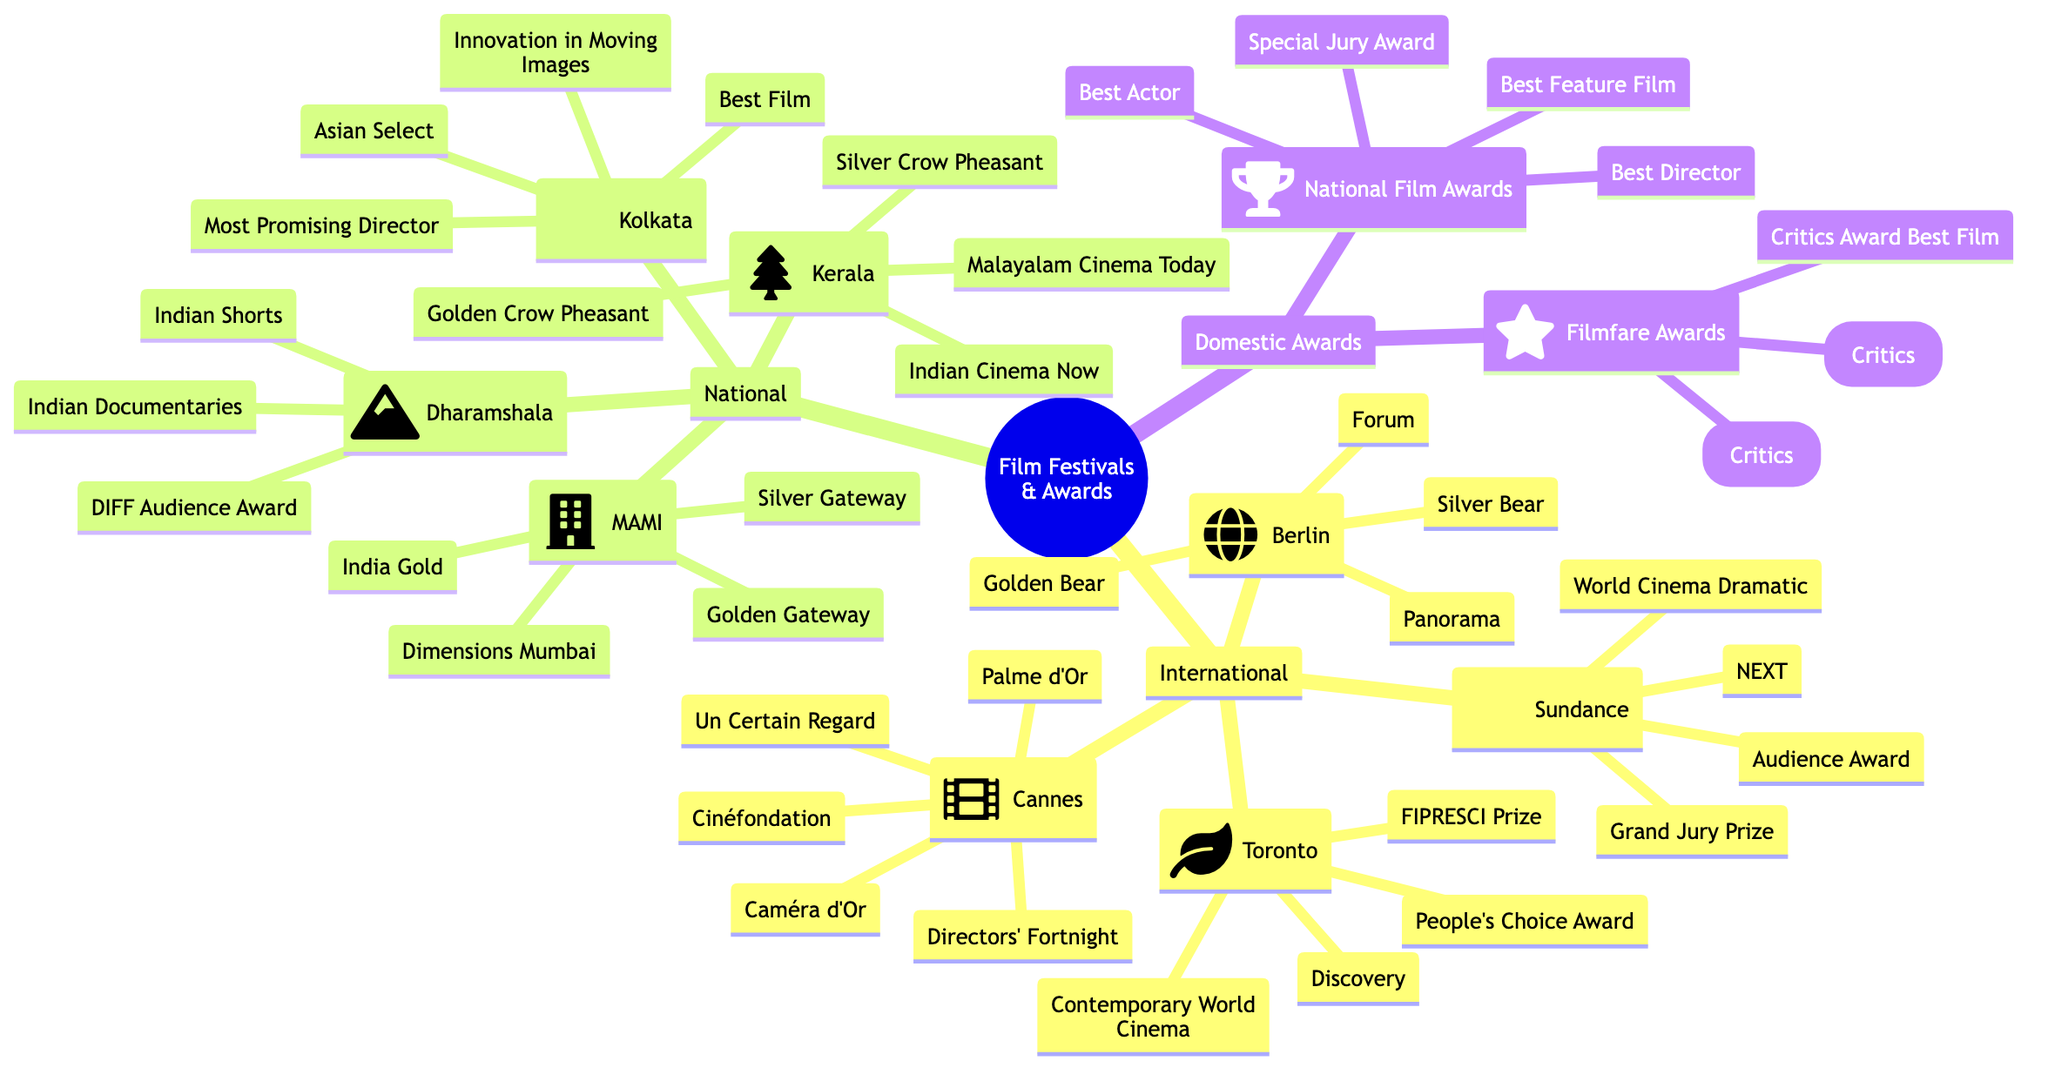What are the two notable awards given at the Cannes Film Festival? The diagram specifies that the notable awards for Cannes are the Palme d'Or and Caméra d'Or.
Answer: Palme d'Or, Caméra d'Or How many key sections are there in the Sundance Film Festival? According to the diagram, the Sundance Film Festival has two key sections: World Cinema Dramatic Competition and NEXT.
Answer: 2 What is one of the notable awards for the Toronto International Film Festival? The diagram lists the People's Choice Award and FIPRESCI Prize as notable awards for the Toronto International Film Festival.
Answer: People's Choice Award Which film festival features a section called "Indian Shorts"? The Dharamshala International Film Festival has a key section called Indian Shorts, as mentioned in the diagram.
Answer: Dharamshala International Film Festival How many national film festivals are represented in the diagram? The diagram shows four national film festivals: Mumbai Film Festival (MAMI), Kolkata International Film Festival, Kerala International Film Festival, and Dharamshala International Film Festival.
Answer: 4 What categories are included in the National Film Awards? The diagram indicates that the National Film Awards include Best Feature Film, Best Director, Best Actor, and Special Jury Award as categories.
Answer: Best Feature Film, Best Director, Best Actor, Special Jury Award Which festival awards the Golden Gateway and Silver Gateway? The Mumbai Film Festival (MAMI) awards the Golden Gateway and Silver Gateway, as stated in the diagram.
Answer: Mumbai Film Festival (MAMI) What is a distinguishing feature of the Berlin International Film Festival? The Berlin International Film Festival is noted for its key sections Panorama and Forum, according to the diagram.
Answer: Panorama, Forum 